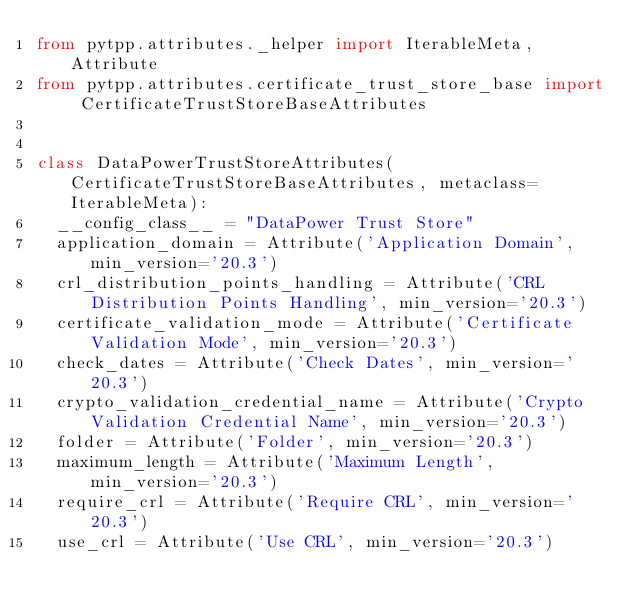Convert code to text. <code><loc_0><loc_0><loc_500><loc_500><_Python_>from pytpp.attributes._helper import IterableMeta, Attribute
from pytpp.attributes.certificate_trust_store_base import CertificateTrustStoreBaseAttributes


class DataPowerTrustStoreAttributes(CertificateTrustStoreBaseAttributes, metaclass=IterableMeta):
	__config_class__ = "DataPower Trust Store"
	application_domain = Attribute('Application Domain', min_version='20.3')
	crl_distribution_points_handling = Attribute('CRL Distribution Points Handling', min_version='20.3')
	certificate_validation_mode = Attribute('Certificate Validation Mode', min_version='20.3')
	check_dates = Attribute('Check Dates', min_version='20.3')
	crypto_validation_credential_name = Attribute('Crypto Validation Credential Name', min_version='20.3')
	folder = Attribute('Folder', min_version='20.3')
	maximum_length = Attribute('Maximum Length', min_version='20.3')
	require_crl = Attribute('Require CRL', min_version='20.3')
	use_crl = Attribute('Use CRL', min_version='20.3')
</code> 